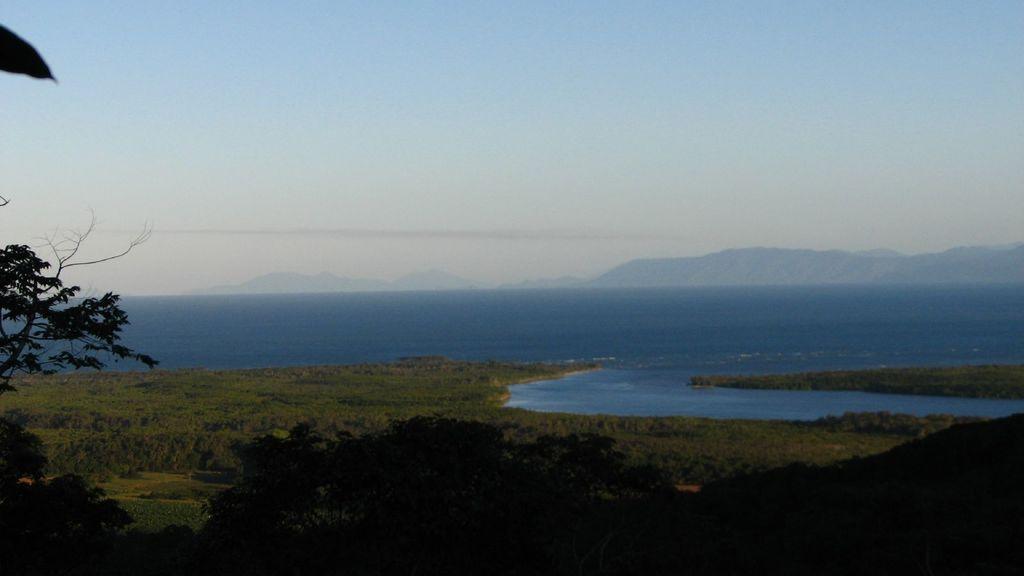Could you give a brief overview of what you see in this image? In this image I can see grass and trees in green color, at the back I can see water in blue color and sky is in blue and white color. 